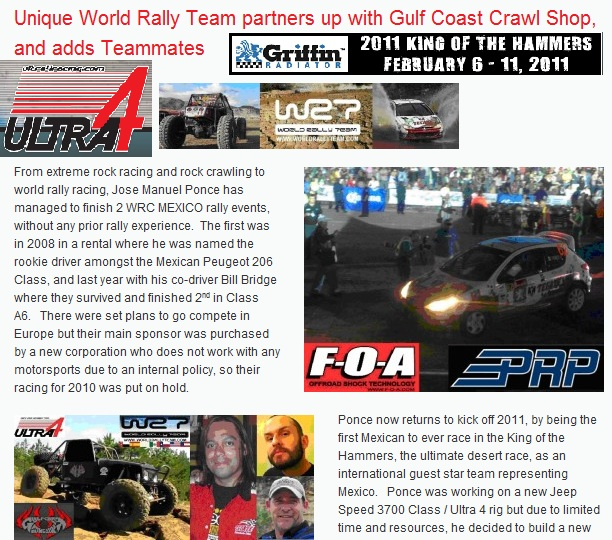If Jose Manuel Ponce was to write an autobiography about his rally racing career, what would be a captivating chapter title for his early experiences? A captivating chapter title for Jose Manuel Ponce's early rally racing experiences might be 'From Rock Crawls to Rally Conquests: The Rookie's Rise'. 